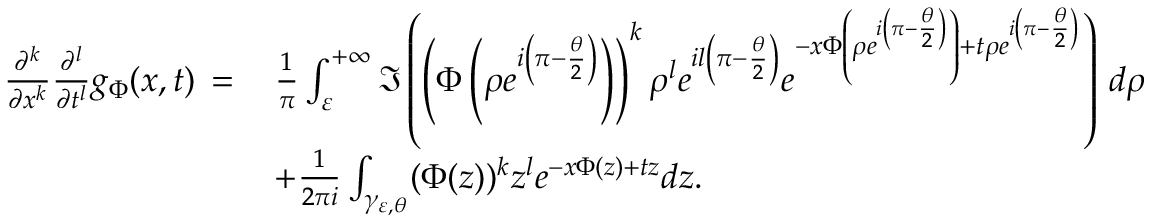Convert formula to latex. <formula><loc_0><loc_0><loc_500><loc_500>\begin{array} { r l } { \frac { \partial ^ { k } } { \partial x ^ { k } } \frac { \partial ^ { l } } { \partial t ^ { l } } g _ { \Phi } ( x , t ) \, = \, } & { \frac { 1 } { \pi } \int _ { \varepsilon } ^ { + \infty } \Im \left ( \left ( \Phi \left ( \rho e ^ { i \left ( \pi - \frac { \theta } { 2 } \right ) } \right ) \right ) ^ { k } \rho ^ { l } e ^ { i l \left ( \pi - \frac { \theta } { 2 } \right ) } e ^ { - x \Phi \left ( \rho e ^ { i \left ( \pi - \frac { \theta } { 2 } \right ) } \right ) + t \rho e ^ { i \left ( \pi - \frac { \theta } { 2 } \right ) } } \right ) \, d \rho } \\ & { + \frac { 1 } { 2 \pi i } \int _ { \gamma _ { \varepsilon , \theta } } ( \Phi ( z ) ) ^ { k } z ^ { l } e ^ { - x \Phi ( z ) + t z } d z . } \end{array}</formula> 